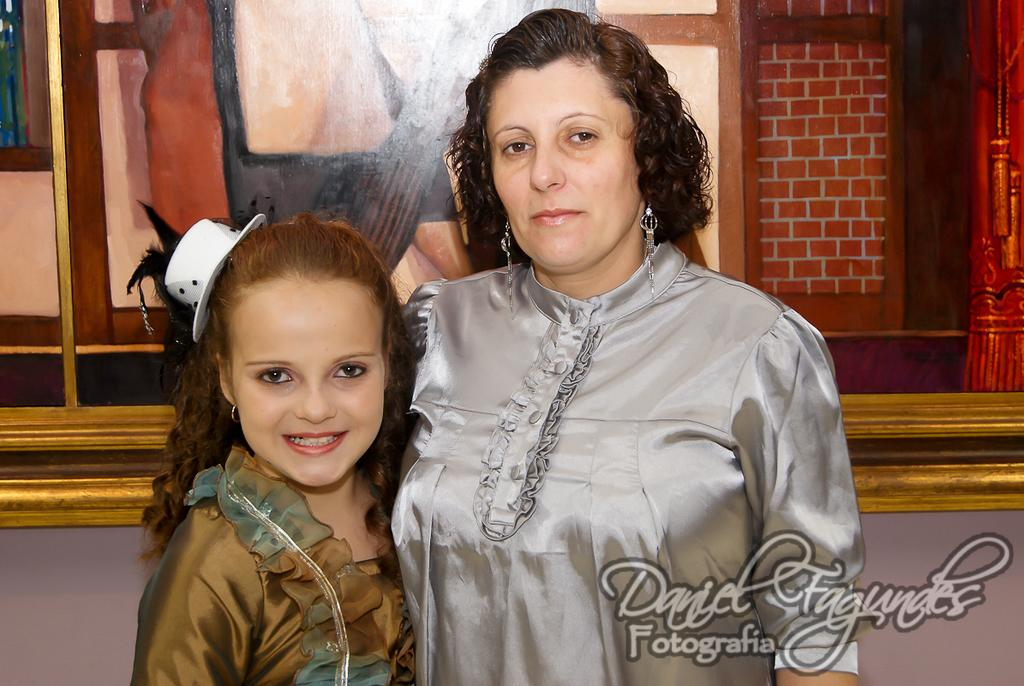Who is present in the image? There is a woman and a child in the image. What are the woman and child doing in the image? The woman and child are standing. What can be seen on the wall in the image? There is a photo frame on the wall in the image. How many owners does the cemetery in the image have? There is no cemetery present in the image, so it is not possible to determine the number of owners. 